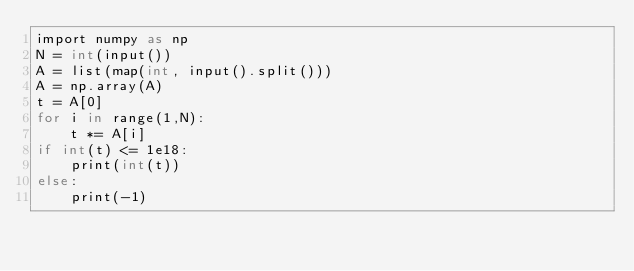<code> <loc_0><loc_0><loc_500><loc_500><_Cython_>import numpy as np
N = int(input())
A = list(map(int, input().split()))
A = np.array(A)
t = A[0]
for i in range(1,N):
    t *= A[i]
if int(t) <= 1e18:
    print(int(t))
else:
    print(-1)
</code> 